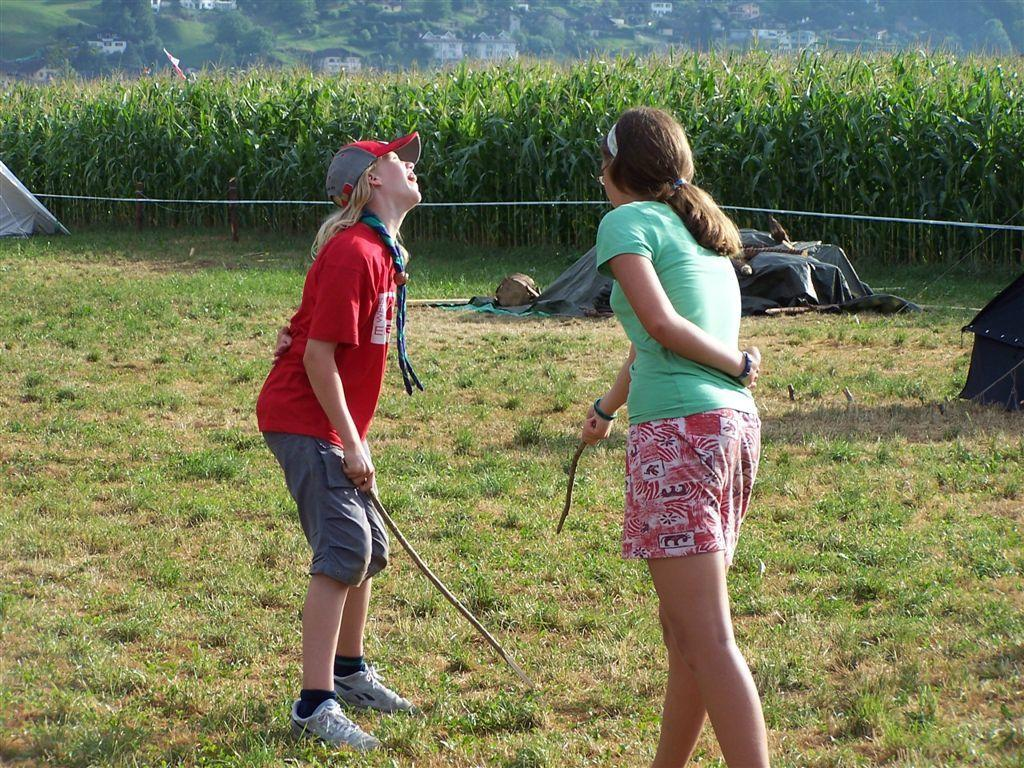How many girls are present in the image? There are two girls in the image. What is the position of the girls in the image? The girls are standing on the ground. What can be seen in the background of the image? There are trees in the background of the image. Where are the dolls being held in the image? There are no dolls present in the image. Is there a jail visible in the image? There is no jail present in the image. 